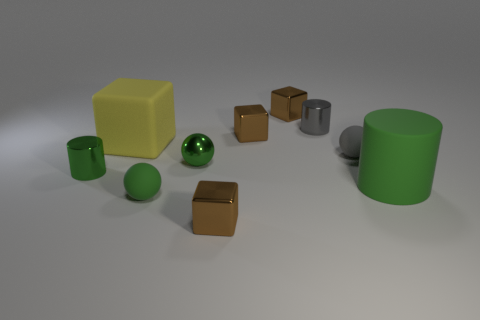Do the large matte cube and the metallic sphere have the same color?
Your answer should be compact. No. How many other things are there of the same shape as the big green thing?
Offer a very short reply. 2. Are there more tiny brown objects that are in front of the matte cylinder than small things to the left of the big yellow rubber cube?
Your answer should be very brief. No. Does the matte object on the right side of the gray rubber sphere have the same size as the object that is left of the big matte cube?
Ensure brevity in your answer.  No. The big green rubber thing is what shape?
Ensure brevity in your answer.  Cylinder. What is the size of the matte thing that is the same color as the large cylinder?
Give a very brief answer. Small. There is a small ball that is the same material as the tiny green cylinder; what color is it?
Make the answer very short. Green. Do the big yellow block and the cylinder in front of the tiny green cylinder have the same material?
Make the answer very short. Yes. What color is the large matte cube?
Your answer should be very brief. Yellow. The green sphere that is made of the same material as the tiny green cylinder is what size?
Offer a very short reply. Small. 